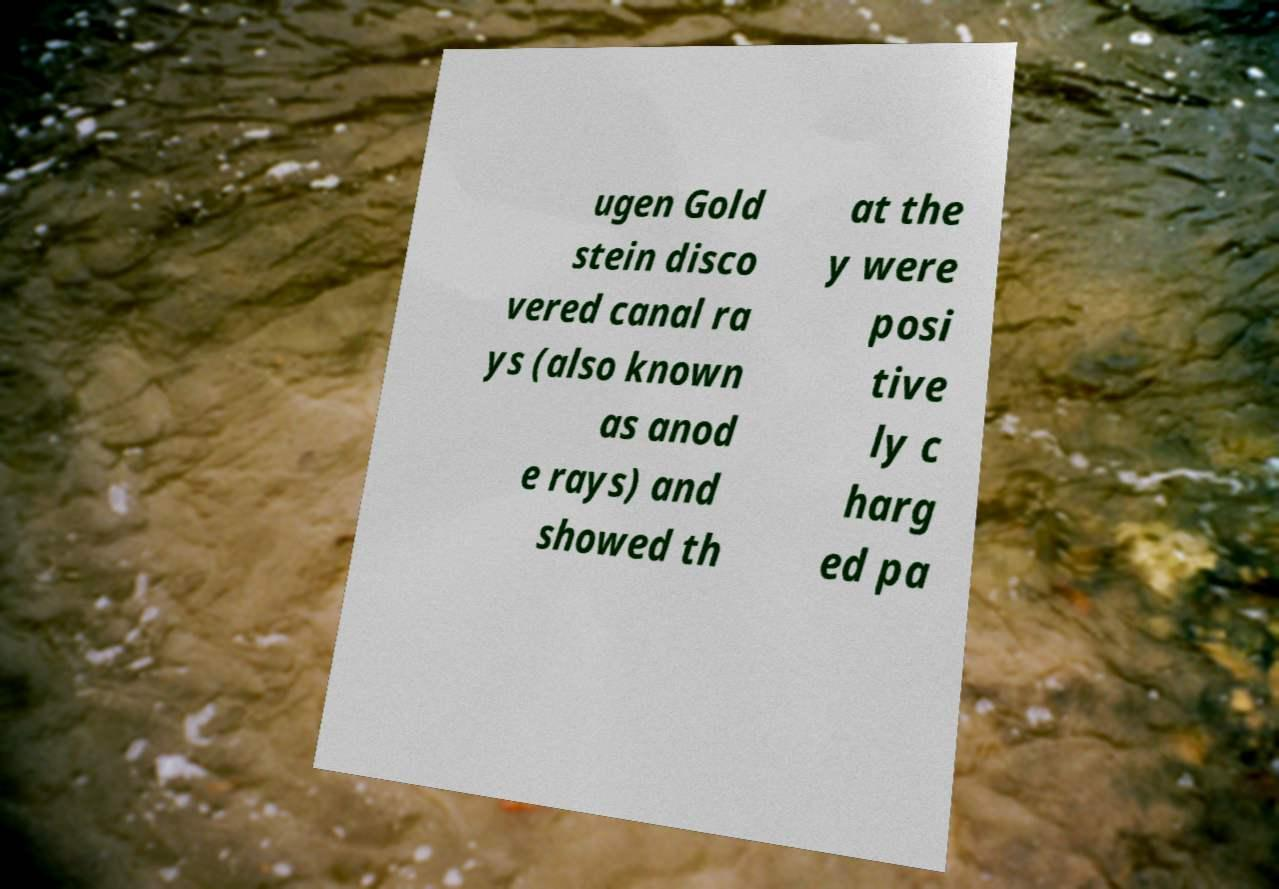Could you assist in decoding the text presented in this image and type it out clearly? ugen Gold stein disco vered canal ra ys (also known as anod e rays) and showed th at the y were posi tive ly c harg ed pa 